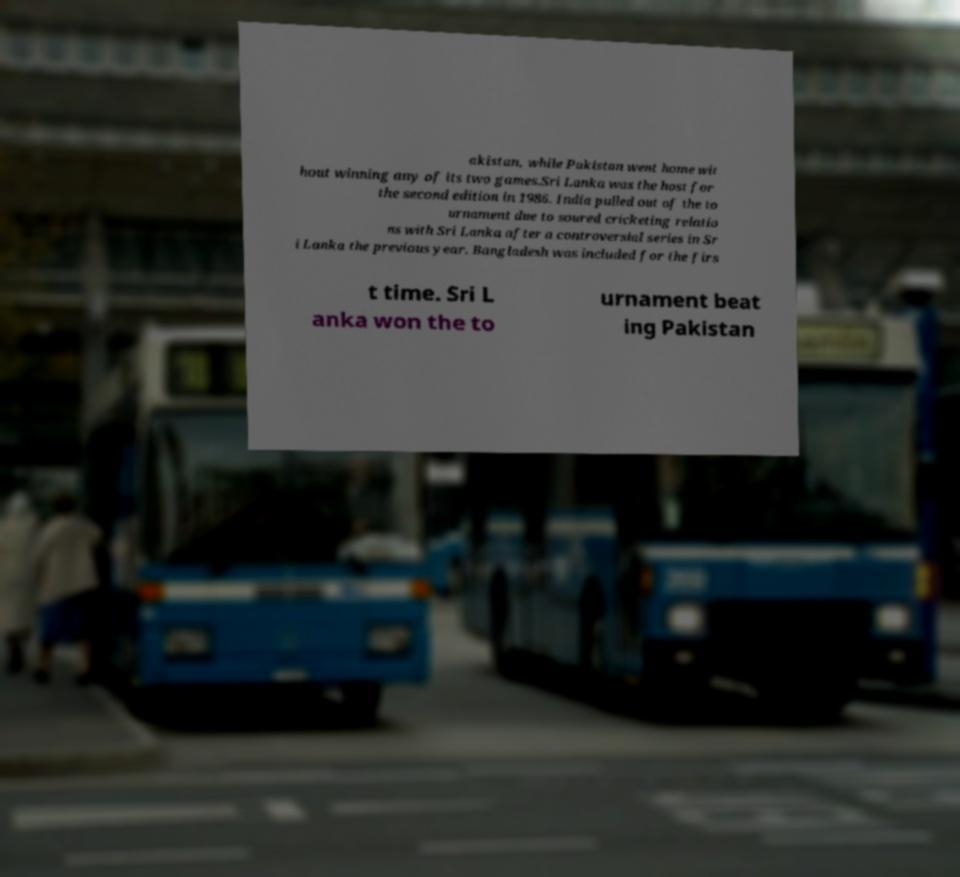There's text embedded in this image that I need extracted. Can you transcribe it verbatim? akistan, while Pakistan went home wit hout winning any of its two games.Sri Lanka was the host for the second edition in 1986. India pulled out of the to urnament due to soured cricketing relatio ns with Sri Lanka after a controversial series in Sr i Lanka the previous year. Bangladesh was included for the firs t time. Sri L anka won the to urnament beat ing Pakistan 